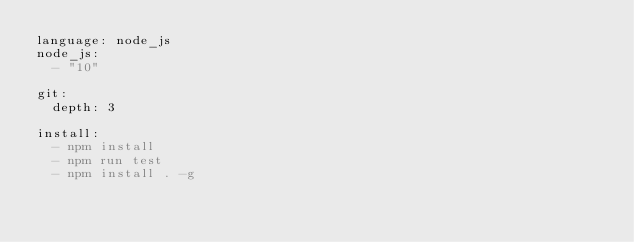Convert code to text. <code><loc_0><loc_0><loc_500><loc_500><_YAML_>language: node_js
node_js:
  - "10"

git:
  depth: 3

install:
  - npm install
  - npm run test
  - npm install . -g
</code> 